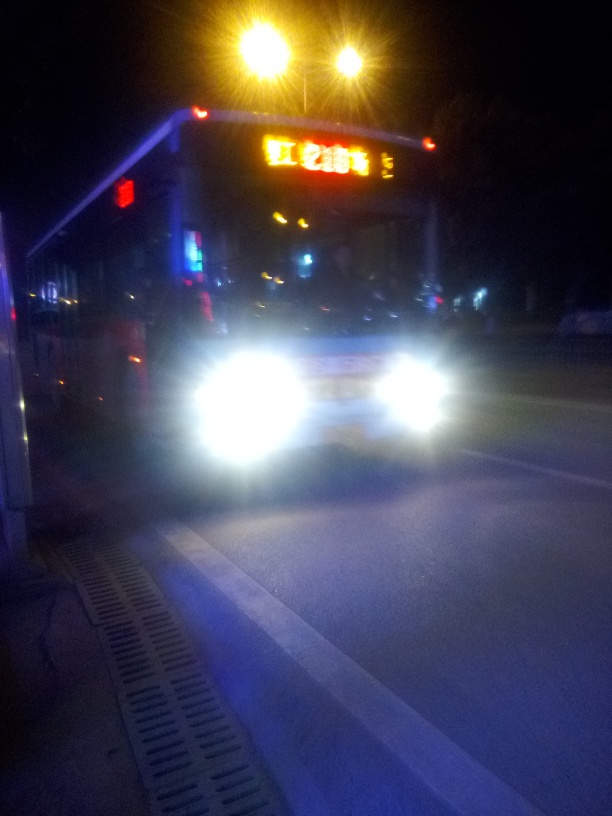What time of day does this photo appear to have been taken? Based on the darkness in the surrounding environment and the artificial lighting from the vehicle’s headlights and the overhead sign, this photo appears to have been taken at night. 